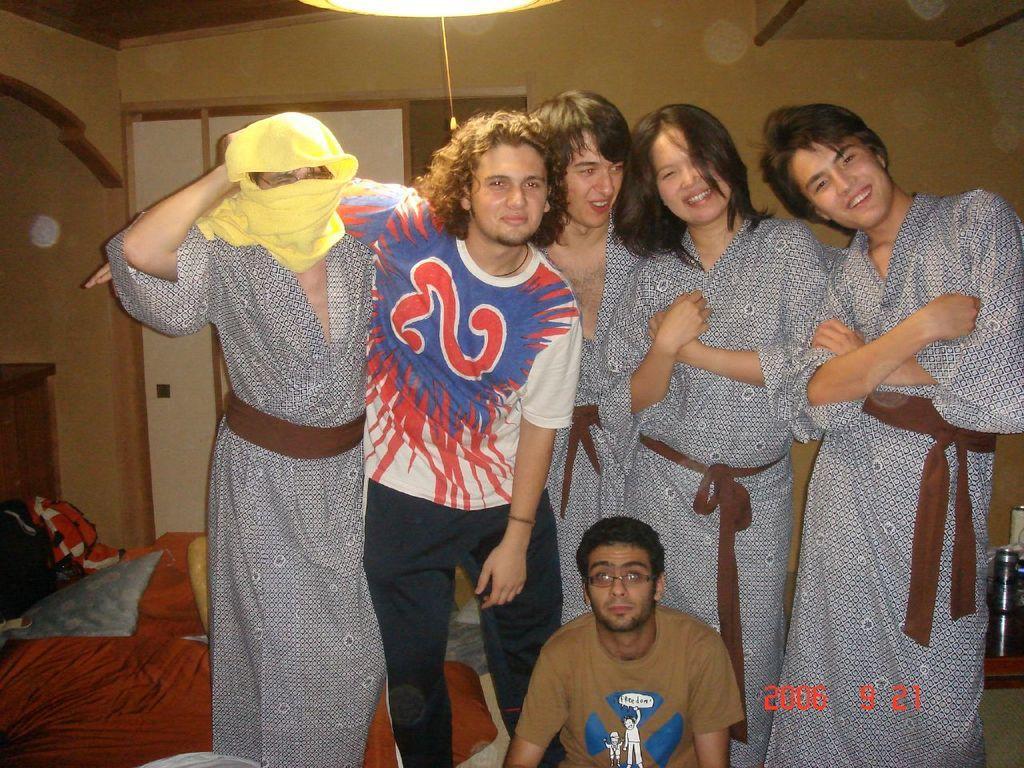Please provide a concise description of this image. This is the picture of a room. In this image there are group of people standing and smiling and there is a person sitting. On the left side of the image there are pillows on the bed and there is a door. On the right side of the image there is a bottle and cup on the table. At the top there is a light. 